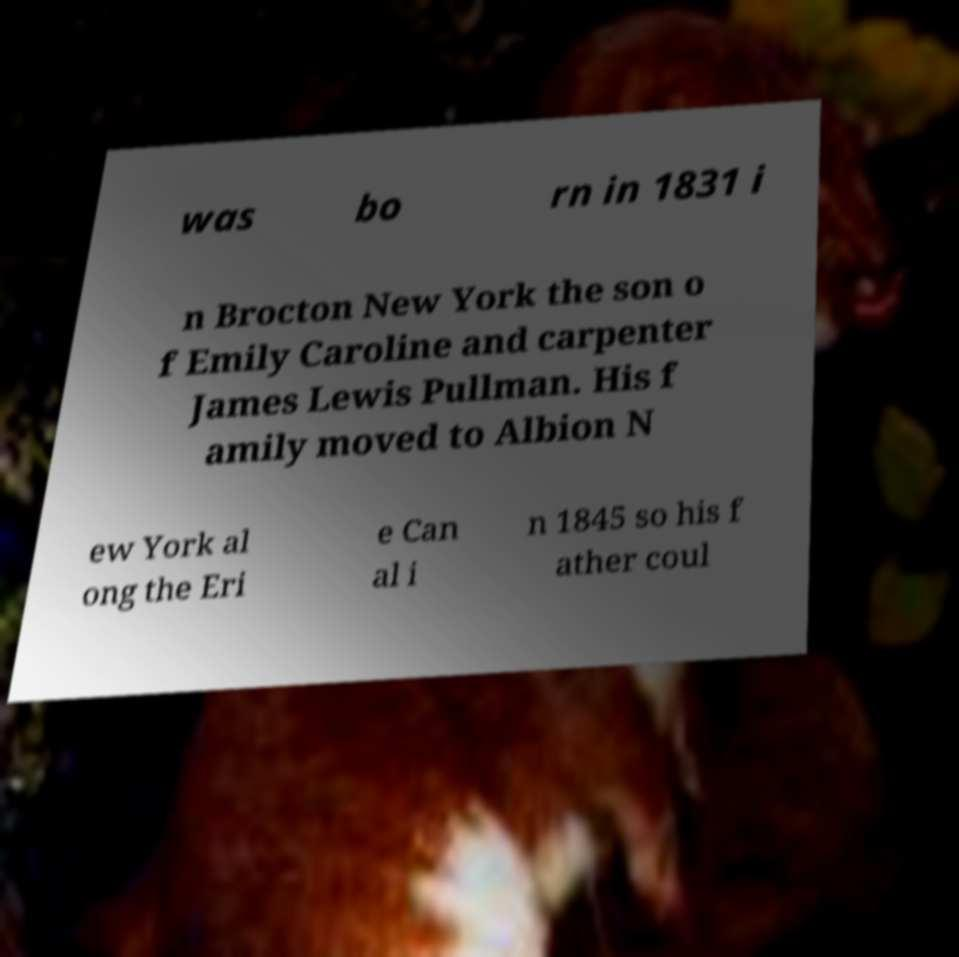Can you accurately transcribe the text from the provided image for me? was bo rn in 1831 i n Brocton New York the son o f Emily Caroline and carpenter James Lewis Pullman. His f amily moved to Albion N ew York al ong the Eri e Can al i n 1845 so his f ather coul 